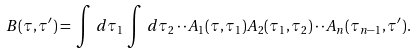Convert formula to latex. <formula><loc_0><loc_0><loc_500><loc_500>B ( \tau , \tau ^ { \prime } ) = \, \int \, d \tau _ { 1 } \, \int \, d \tau _ { 2 } \cdot \cdot A _ { 1 } ( \tau , \tau _ { 1 } ) A _ { 2 } ( \tau _ { 1 } , \tau _ { 2 } ) \cdot \cdot A _ { n } ( \tau _ { n - 1 } , \tau ^ { \prime } ) .</formula> 